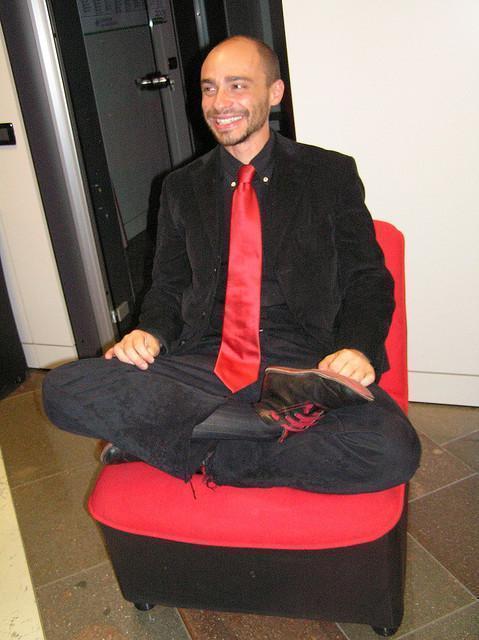What is the man wearing?
Pick the correct solution from the four options below to address the question.
Options: Boa, crown, armor, tie. Tie. 